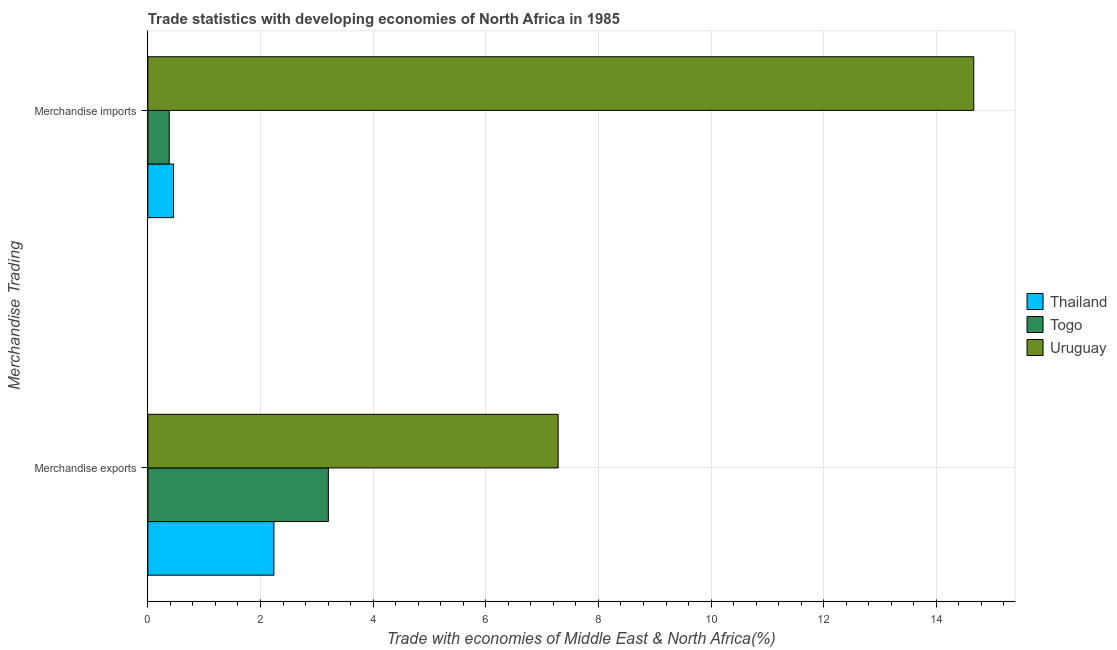How many groups of bars are there?
Keep it short and to the point. 2. Are the number of bars per tick equal to the number of legend labels?
Keep it short and to the point. Yes. Are the number of bars on each tick of the Y-axis equal?
Keep it short and to the point. Yes. How many bars are there on the 2nd tick from the top?
Your answer should be very brief. 3. What is the merchandise exports in Thailand?
Your answer should be very brief. 2.24. Across all countries, what is the maximum merchandise imports?
Your answer should be very brief. 14.66. Across all countries, what is the minimum merchandise exports?
Ensure brevity in your answer.  2.24. In which country was the merchandise imports maximum?
Keep it short and to the point. Uruguay. In which country was the merchandise imports minimum?
Make the answer very short. Togo. What is the total merchandise imports in the graph?
Provide a short and direct response. 15.5. What is the difference between the merchandise exports in Thailand and that in Togo?
Your answer should be compact. -0.97. What is the difference between the merchandise imports in Togo and the merchandise exports in Uruguay?
Provide a succinct answer. -6.9. What is the average merchandise imports per country?
Offer a terse response. 5.17. What is the difference between the merchandise imports and merchandise exports in Togo?
Keep it short and to the point. -2.83. In how many countries, is the merchandise imports greater than 4 %?
Keep it short and to the point. 1. What is the ratio of the merchandise imports in Thailand to that in Togo?
Your answer should be compact. 1.2. What does the 2nd bar from the top in Merchandise exports represents?
Give a very brief answer. Togo. What does the 3rd bar from the bottom in Merchandise exports represents?
Provide a succinct answer. Uruguay. How many bars are there?
Make the answer very short. 6. Are all the bars in the graph horizontal?
Provide a succinct answer. Yes. How many countries are there in the graph?
Your response must be concise. 3. What is the difference between two consecutive major ticks on the X-axis?
Your answer should be very brief. 2. Does the graph contain any zero values?
Give a very brief answer. No. Where does the legend appear in the graph?
Give a very brief answer. Center right. How many legend labels are there?
Offer a terse response. 3. How are the legend labels stacked?
Make the answer very short. Vertical. What is the title of the graph?
Provide a short and direct response. Trade statistics with developing economies of North Africa in 1985. Does "Europe(all income levels)" appear as one of the legend labels in the graph?
Provide a succinct answer. No. What is the label or title of the X-axis?
Make the answer very short. Trade with economies of Middle East & North Africa(%). What is the label or title of the Y-axis?
Your answer should be very brief. Merchandise Trading. What is the Trade with economies of Middle East & North Africa(%) in Thailand in Merchandise exports?
Ensure brevity in your answer.  2.24. What is the Trade with economies of Middle East & North Africa(%) in Togo in Merchandise exports?
Your answer should be compact. 3.2. What is the Trade with economies of Middle East & North Africa(%) in Uruguay in Merchandise exports?
Provide a short and direct response. 7.28. What is the Trade with economies of Middle East & North Africa(%) of Thailand in Merchandise imports?
Offer a very short reply. 0.46. What is the Trade with economies of Middle East & North Africa(%) in Togo in Merchandise imports?
Ensure brevity in your answer.  0.38. What is the Trade with economies of Middle East & North Africa(%) of Uruguay in Merchandise imports?
Give a very brief answer. 14.66. Across all Merchandise Trading, what is the maximum Trade with economies of Middle East & North Africa(%) in Thailand?
Provide a short and direct response. 2.24. Across all Merchandise Trading, what is the maximum Trade with economies of Middle East & North Africa(%) in Togo?
Your response must be concise. 3.2. Across all Merchandise Trading, what is the maximum Trade with economies of Middle East & North Africa(%) in Uruguay?
Offer a terse response. 14.66. Across all Merchandise Trading, what is the minimum Trade with economies of Middle East & North Africa(%) in Thailand?
Your response must be concise. 0.46. Across all Merchandise Trading, what is the minimum Trade with economies of Middle East & North Africa(%) in Togo?
Provide a succinct answer. 0.38. Across all Merchandise Trading, what is the minimum Trade with economies of Middle East & North Africa(%) in Uruguay?
Your response must be concise. 7.28. What is the total Trade with economies of Middle East & North Africa(%) of Thailand in the graph?
Ensure brevity in your answer.  2.69. What is the total Trade with economies of Middle East & North Africa(%) of Togo in the graph?
Give a very brief answer. 3.58. What is the total Trade with economies of Middle East & North Africa(%) of Uruguay in the graph?
Provide a short and direct response. 21.95. What is the difference between the Trade with economies of Middle East & North Africa(%) in Thailand in Merchandise exports and that in Merchandise imports?
Your response must be concise. 1.78. What is the difference between the Trade with economies of Middle East & North Africa(%) of Togo in Merchandise exports and that in Merchandise imports?
Make the answer very short. 2.83. What is the difference between the Trade with economies of Middle East & North Africa(%) of Uruguay in Merchandise exports and that in Merchandise imports?
Ensure brevity in your answer.  -7.38. What is the difference between the Trade with economies of Middle East & North Africa(%) in Thailand in Merchandise exports and the Trade with economies of Middle East & North Africa(%) in Togo in Merchandise imports?
Offer a terse response. 1.86. What is the difference between the Trade with economies of Middle East & North Africa(%) in Thailand in Merchandise exports and the Trade with economies of Middle East & North Africa(%) in Uruguay in Merchandise imports?
Provide a short and direct response. -12.43. What is the difference between the Trade with economies of Middle East & North Africa(%) in Togo in Merchandise exports and the Trade with economies of Middle East & North Africa(%) in Uruguay in Merchandise imports?
Keep it short and to the point. -11.46. What is the average Trade with economies of Middle East & North Africa(%) in Thailand per Merchandise Trading?
Offer a terse response. 1.35. What is the average Trade with economies of Middle East & North Africa(%) in Togo per Merchandise Trading?
Provide a short and direct response. 1.79. What is the average Trade with economies of Middle East & North Africa(%) in Uruguay per Merchandise Trading?
Provide a succinct answer. 10.97. What is the difference between the Trade with economies of Middle East & North Africa(%) of Thailand and Trade with economies of Middle East & North Africa(%) of Togo in Merchandise exports?
Ensure brevity in your answer.  -0.97. What is the difference between the Trade with economies of Middle East & North Africa(%) in Thailand and Trade with economies of Middle East & North Africa(%) in Uruguay in Merchandise exports?
Provide a short and direct response. -5.05. What is the difference between the Trade with economies of Middle East & North Africa(%) of Togo and Trade with economies of Middle East & North Africa(%) of Uruguay in Merchandise exports?
Make the answer very short. -4.08. What is the difference between the Trade with economies of Middle East & North Africa(%) of Thailand and Trade with economies of Middle East & North Africa(%) of Togo in Merchandise imports?
Give a very brief answer. 0.08. What is the difference between the Trade with economies of Middle East & North Africa(%) in Thailand and Trade with economies of Middle East & North Africa(%) in Uruguay in Merchandise imports?
Provide a succinct answer. -14.21. What is the difference between the Trade with economies of Middle East & North Africa(%) of Togo and Trade with economies of Middle East & North Africa(%) of Uruguay in Merchandise imports?
Provide a succinct answer. -14.28. What is the ratio of the Trade with economies of Middle East & North Africa(%) of Thailand in Merchandise exports to that in Merchandise imports?
Keep it short and to the point. 4.91. What is the ratio of the Trade with economies of Middle East & North Africa(%) in Togo in Merchandise exports to that in Merchandise imports?
Offer a very short reply. 8.45. What is the ratio of the Trade with economies of Middle East & North Africa(%) in Uruguay in Merchandise exports to that in Merchandise imports?
Provide a short and direct response. 0.5. What is the difference between the highest and the second highest Trade with economies of Middle East & North Africa(%) in Thailand?
Give a very brief answer. 1.78. What is the difference between the highest and the second highest Trade with economies of Middle East & North Africa(%) in Togo?
Your response must be concise. 2.83. What is the difference between the highest and the second highest Trade with economies of Middle East & North Africa(%) in Uruguay?
Offer a terse response. 7.38. What is the difference between the highest and the lowest Trade with economies of Middle East & North Africa(%) in Thailand?
Give a very brief answer. 1.78. What is the difference between the highest and the lowest Trade with economies of Middle East & North Africa(%) of Togo?
Provide a short and direct response. 2.83. What is the difference between the highest and the lowest Trade with economies of Middle East & North Africa(%) of Uruguay?
Make the answer very short. 7.38. 